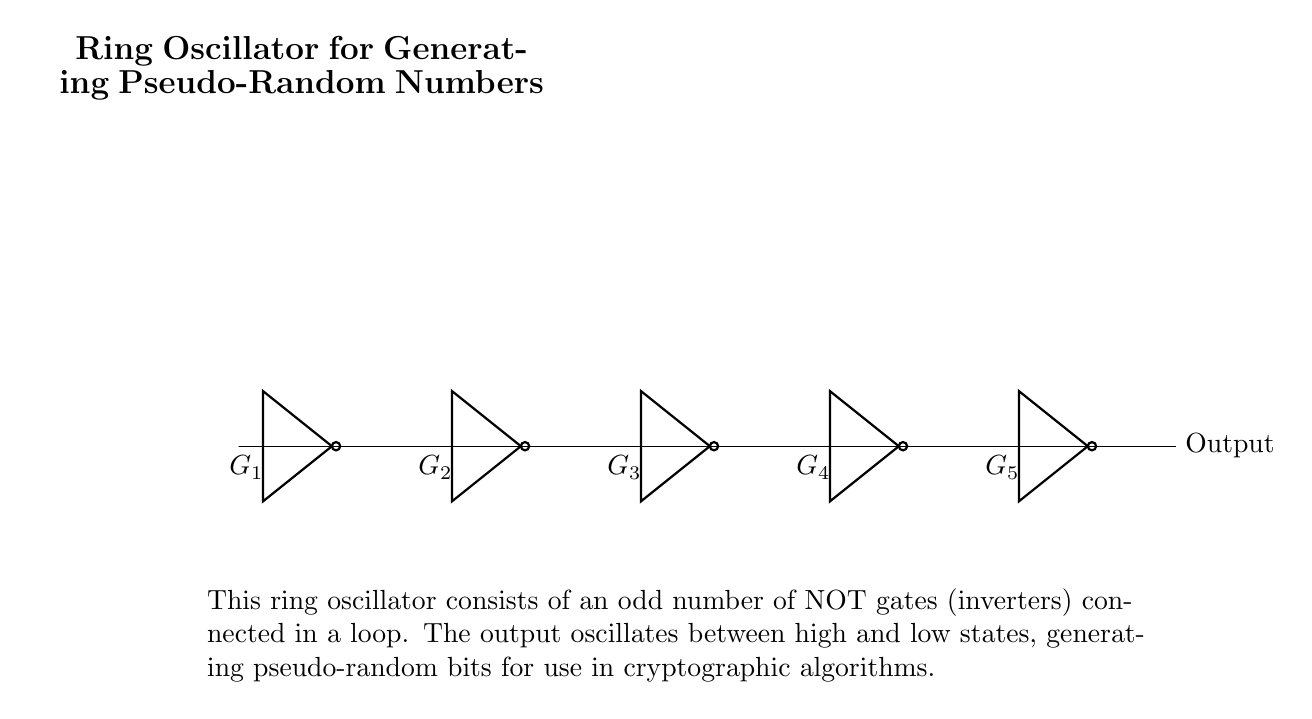What type of gates are used in the ring oscillator? The circuit diagram shows that it consists of multiple NOT gates, which are also called inverters, connected in a loop. Each NOT gate inverts the input signal, contributing to the oscillation.
Answer: NOT gates How many NOT gates are present in the ring oscillator? The diagram clearly shows five NOT gates connected in a circular arrangement. Count the icons for EACH NOT gate to arrive at the total count.
Answer: Five What is the output of the ring oscillator? The output is indicated to oscillate between high and low states, creating pseudo-random bits as shown by the label connected to the last NOT gate. This is fundamental for its use in cryptographic algorithms.
Answer: Output Why is an odd number of gates used in this configuration? Using an odd number of gates ensures that the logic feedback will oscillate, avoiding any stable conditions that can arise with an even number of gates. This allows for continuous toggling of output states, which is necessary for generating the pseudo-random numbers.
Answer: To ensure oscillation What type of output is generated by the ring oscillator? The output is described as pseudo-random bits, which implies that the data generated does not follow a predictable sequence and is suitable for cryptographic applications. This randomness is vital for security purposes.
Answer: Pseudo-random bits What is the purpose of this ring oscillator in cryptographic algorithms? The oscillator's primary purpose is to generate pseudo-random numbers that are used to enhance security in cryptographic systems, providing variability and unpredictability to encryption keys and other secure operations.
Answer: To generate pseudo-random numbers 